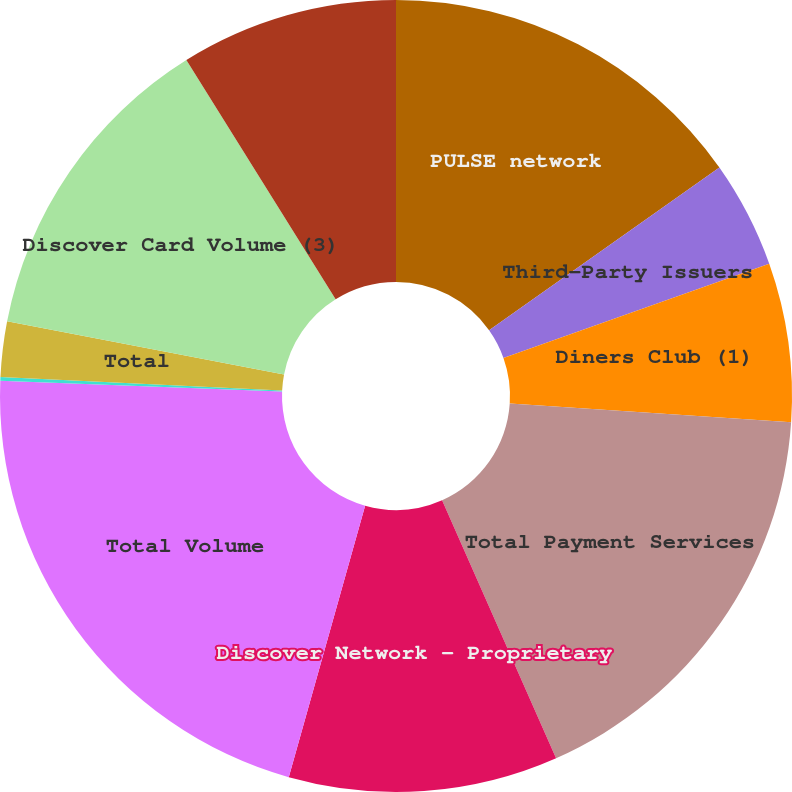Convert chart to OTSL. <chart><loc_0><loc_0><loc_500><loc_500><pie_chart><fcel>PULSE network<fcel>Third-Party Issuers<fcel>Diners Club (1)<fcel>Total Payment Services<fcel>Discover Network - Proprietary<fcel>Total Volume<fcel>Discover Network<fcel>Total<fcel>Discover Card Volume (3)<fcel>Discover Card Sales Volume (4)<nl><fcel>15.21%<fcel>4.37%<fcel>6.48%<fcel>17.32%<fcel>10.99%<fcel>21.25%<fcel>0.15%<fcel>2.26%<fcel>13.1%<fcel>8.88%<nl></chart> 